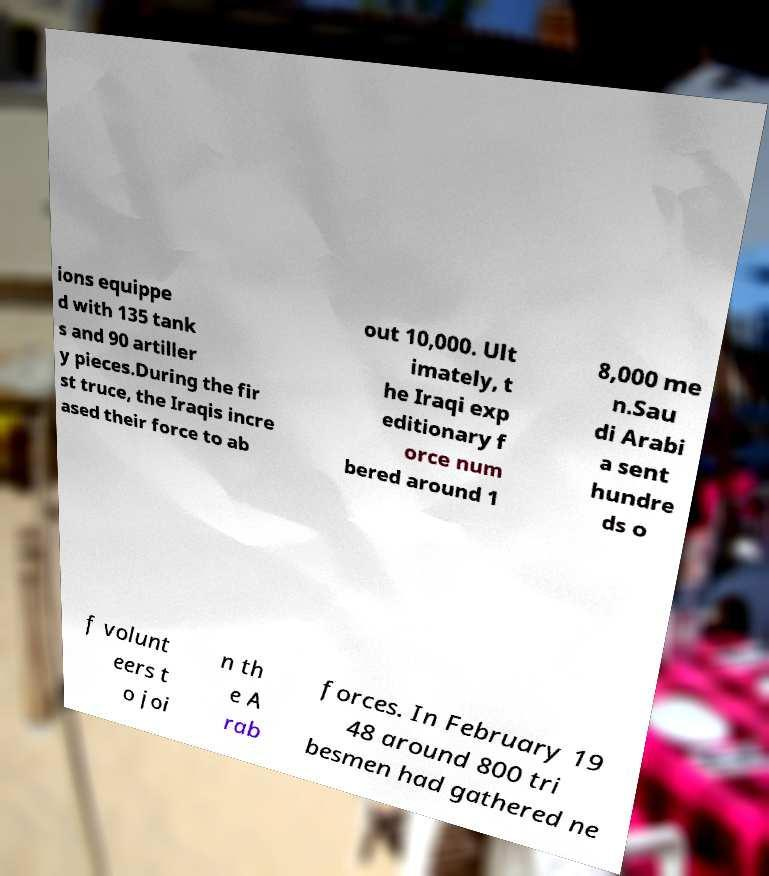Please identify and transcribe the text found in this image. ions equippe d with 135 tank s and 90 artiller y pieces.During the fir st truce, the Iraqis incre ased their force to ab out 10,000. Ult imately, t he Iraqi exp editionary f orce num bered around 1 8,000 me n.Sau di Arabi a sent hundre ds o f volunt eers t o joi n th e A rab forces. In February 19 48 around 800 tri besmen had gathered ne 